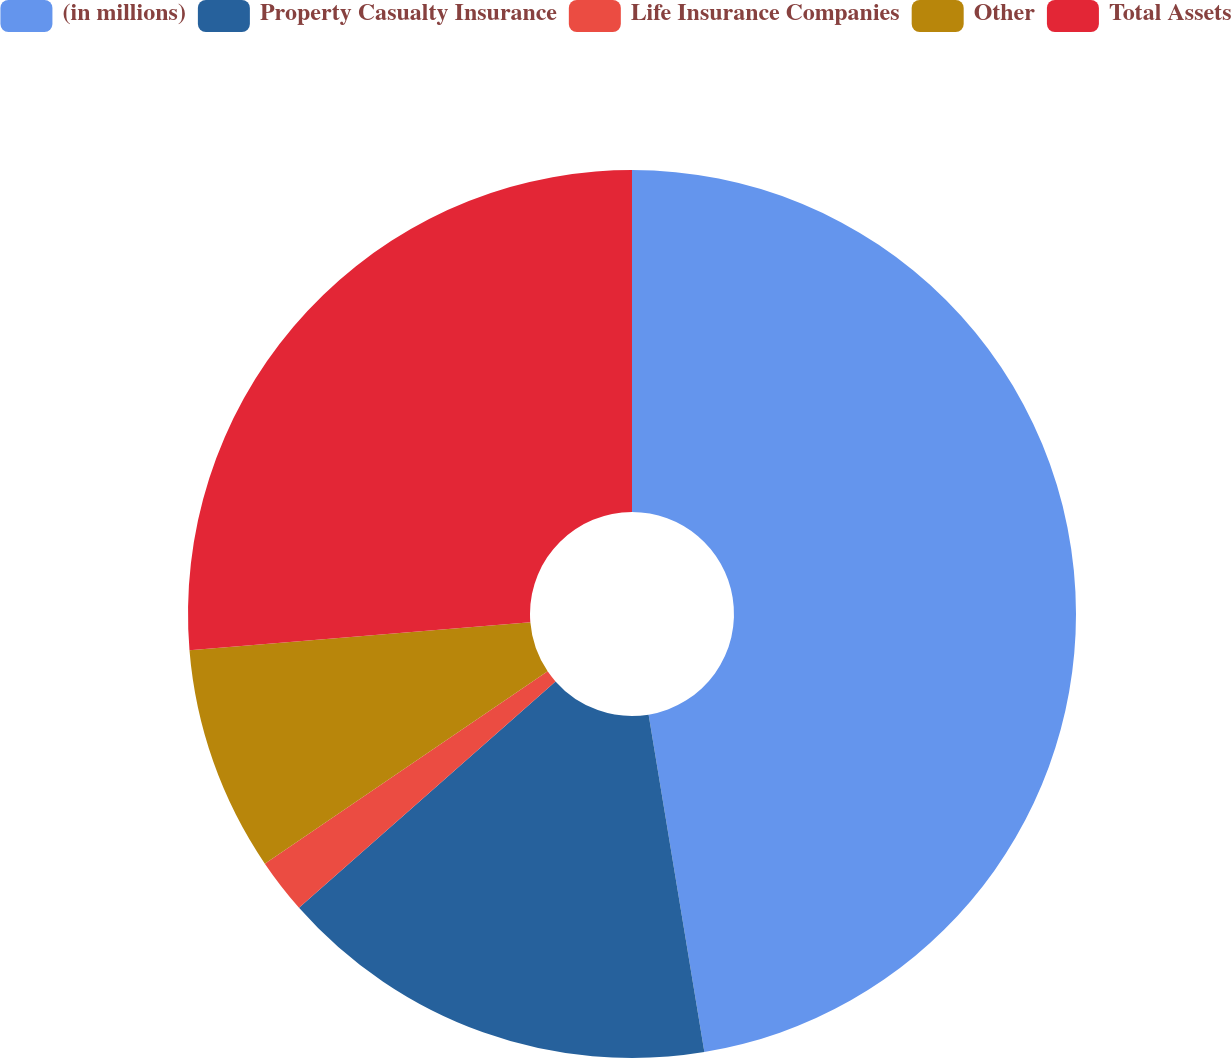Convert chart to OTSL. <chart><loc_0><loc_0><loc_500><loc_500><pie_chart><fcel>(in millions)<fcel>Property Casualty Insurance<fcel>Life Insurance Companies<fcel>Other<fcel>Total Assets<nl><fcel>47.39%<fcel>16.1%<fcel>2.0%<fcel>8.2%<fcel>26.3%<nl></chart> 